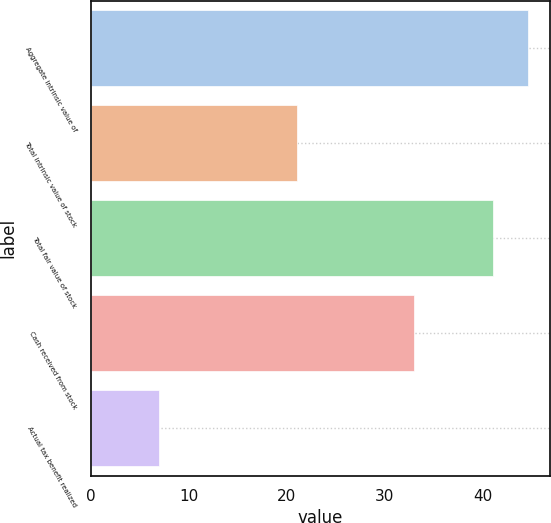<chart> <loc_0><loc_0><loc_500><loc_500><bar_chart><fcel>Aggregate intrinsic value of<fcel>Total intrinsic value of stock<fcel>Total fair value of stock<fcel>Cash received from stock<fcel>Actual tax benefit realized<nl><fcel>44.6<fcel>21<fcel>41<fcel>33<fcel>7<nl></chart> 